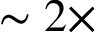<formula> <loc_0><loc_0><loc_500><loc_500>\sim 2 \times</formula> 